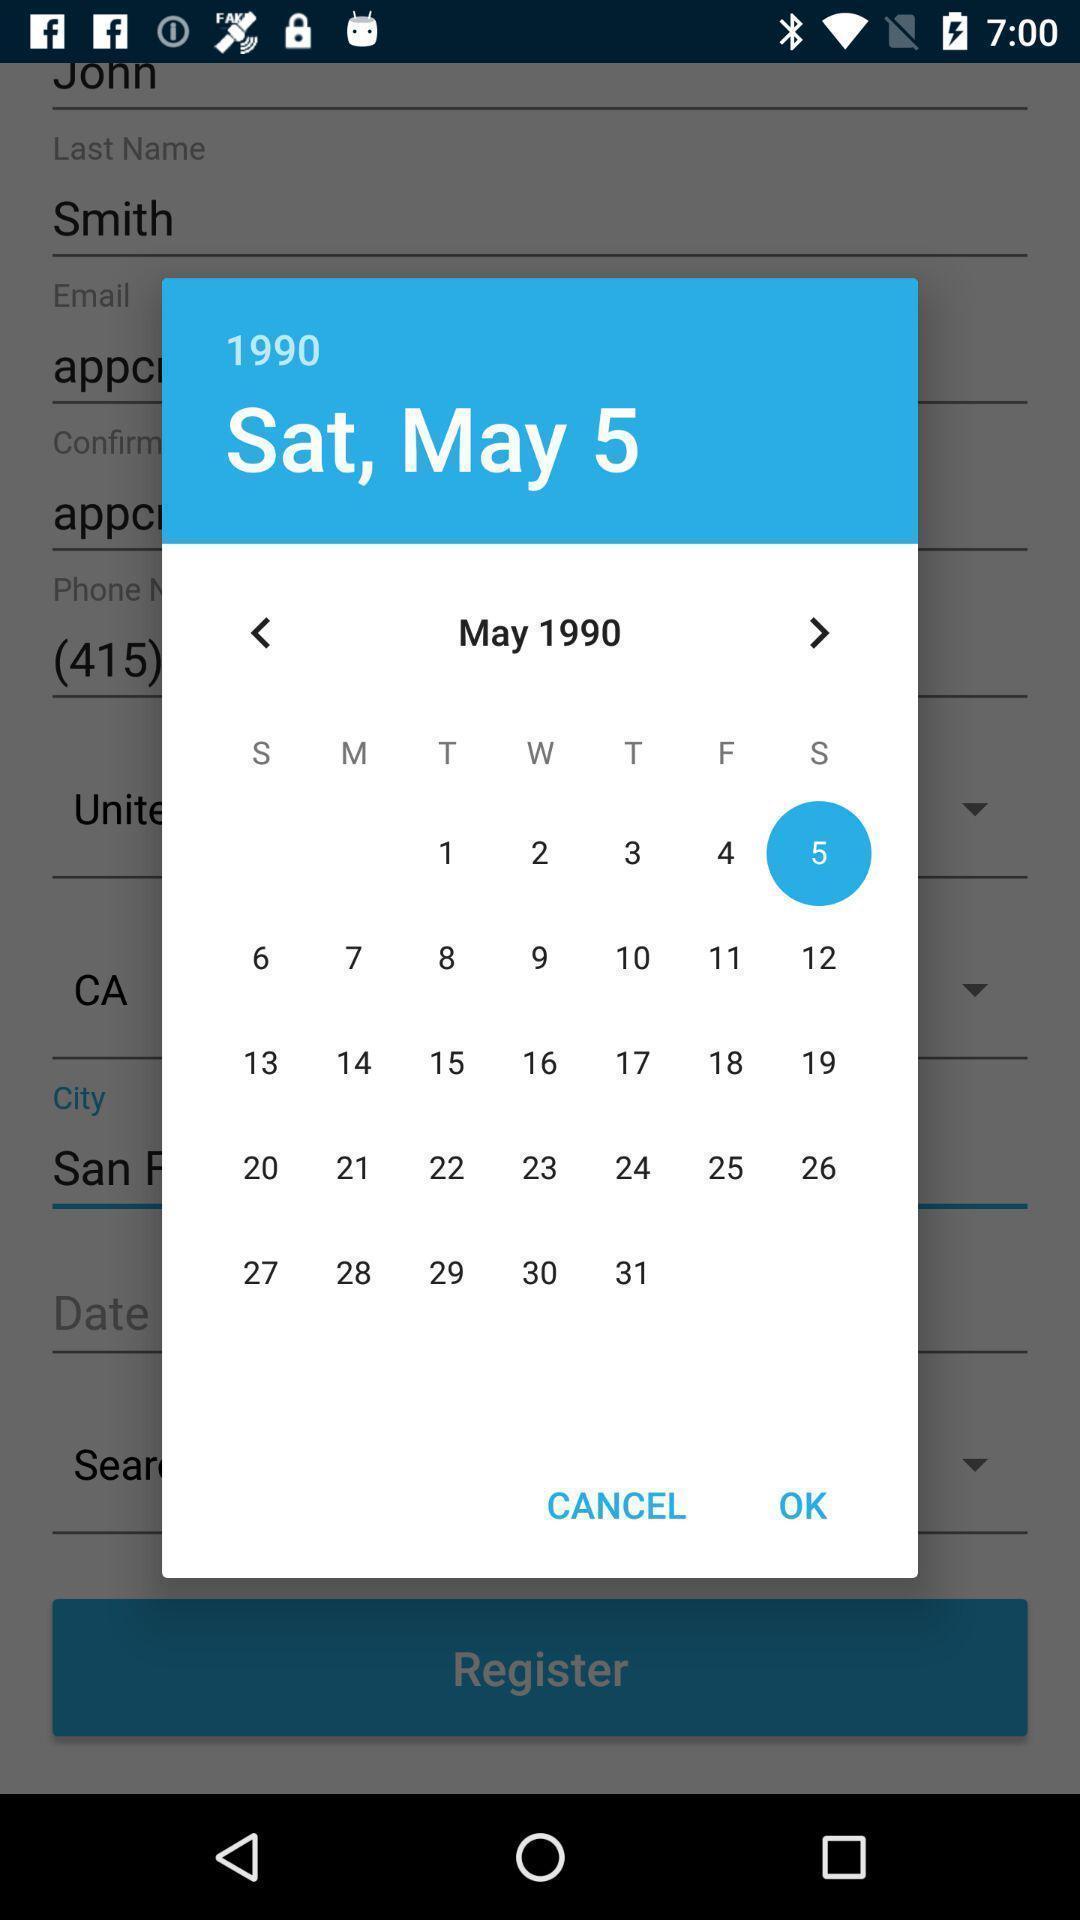Provide a detailed account of this screenshot. Pop-up showing calendar. 